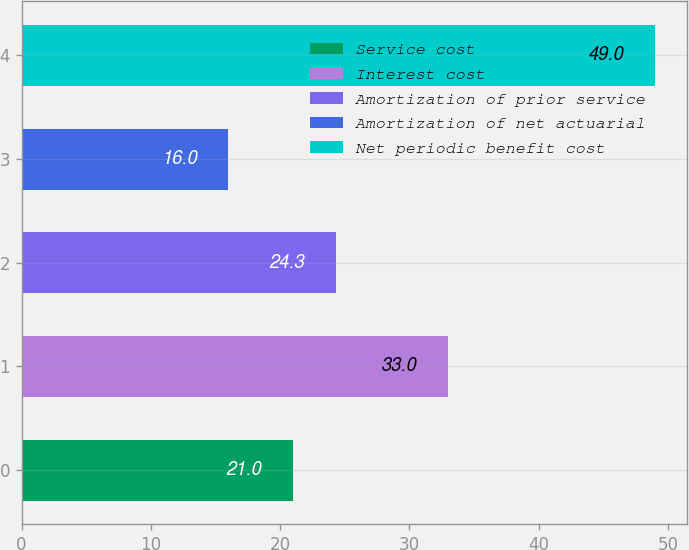Convert chart. <chart><loc_0><loc_0><loc_500><loc_500><bar_chart><fcel>Service cost<fcel>Interest cost<fcel>Amortization of prior service<fcel>Amortization of net actuarial<fcel>Net periodic benefit cost<nl><fcel>21<fcel>33<fcel>24.3<fcel>16<fcel>49<nl></chart> 